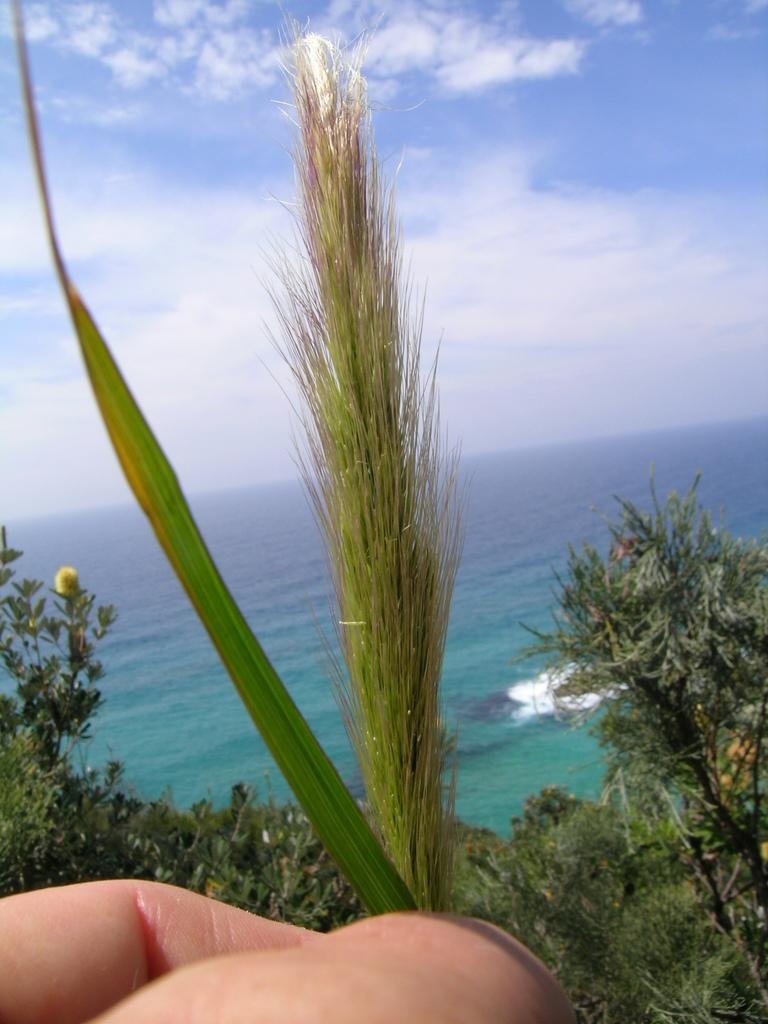What can be seen in the bottom left corner of the image? There are two fingers in the bottom left corner of the image. What type of vegetation is visible in the image? There are plants and grass visible in the image. What is the water feature in the image? There is water visible in the image. What is visible in the sky at the top of the image? There are clouds in the sky at the top of the image. What type of drum is being played in the image? There is no drum present in the image. How many stamps are visible on the grass in the image? There are no stamps visible in the image. 